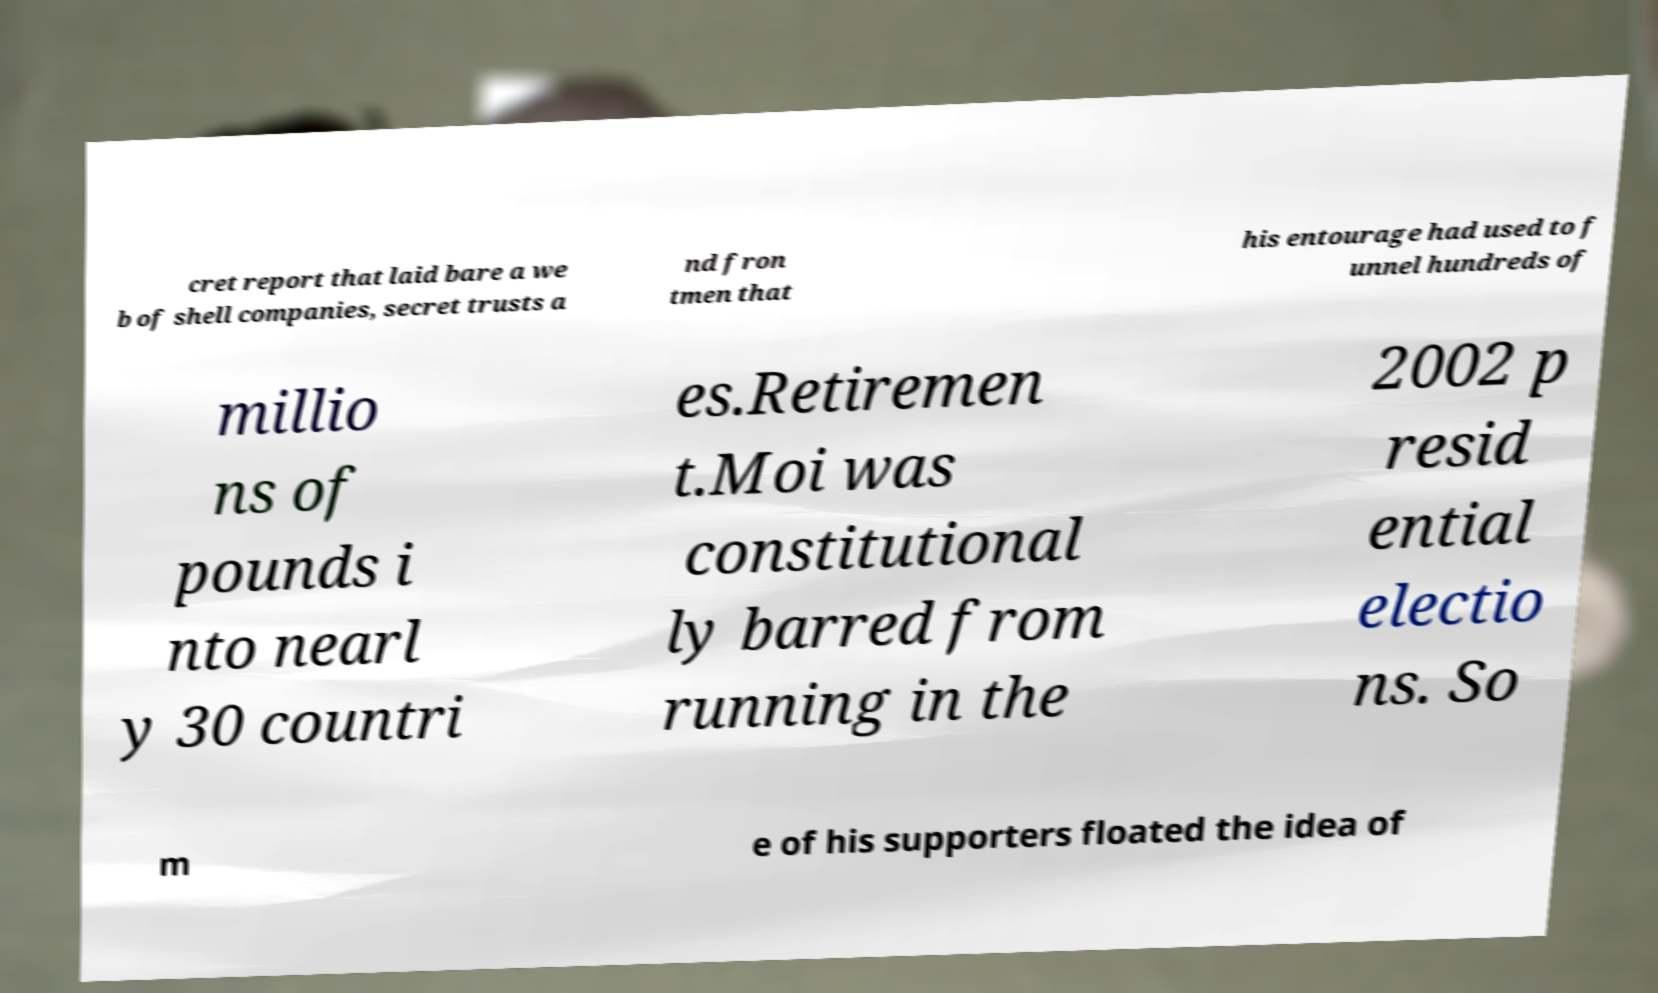Can you read and provide the text displayed in the image?This photo seems to have some interesting text. Can you extract and type it out for me? cret report that laid bare a we b of shell companies, secret trusts a nd fron tmen that his entourage had used to f unnel hundreds of millio ns of pounds i nto nearl y 30 countri es.Retiremen t.Moi was constitutional ly barred from running in the 2002 p resid ential electio ns. So m e of his supporters floated the idea of 